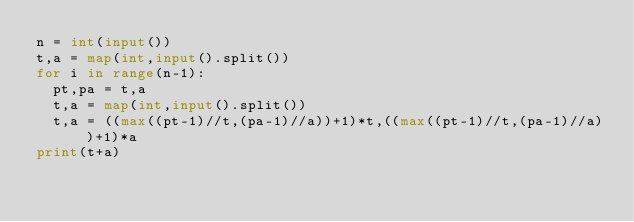Convert code to text. <code><loc_0><loc_0><loc_500><loc_500><_Python_>n = int(input())
t,a = map(int,input().split())
for i in range(n-1):
  pt,pa = t,a
  t,a = map(int,input().split())
  t,a = ((max((pt-1)//t,(pa-1)//a))+1)*t,((max((pt-1)//t,(pa-1)//a))+1)*a
print(t+a)</code> 